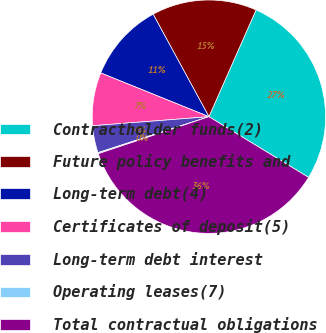<chart> <loc_0><loc_0><loc_500><loc_500><pie_chart><fcel>Contractholder funds(2)<fcel>Future policy benefits and<fcel>Long-term debt(4)<fcel>Certificates of deposit(5)<fcel>Long-term debt interest<fcel>Operating leases(7)<fcel>Total contractual obligations<nl><fcel>27.09%<fcel>14.55%<fcel>10.95%<fcel>7.35%<fcel>3.75%<fcel>0.15%<fcel>36.15%<nl></chart> 